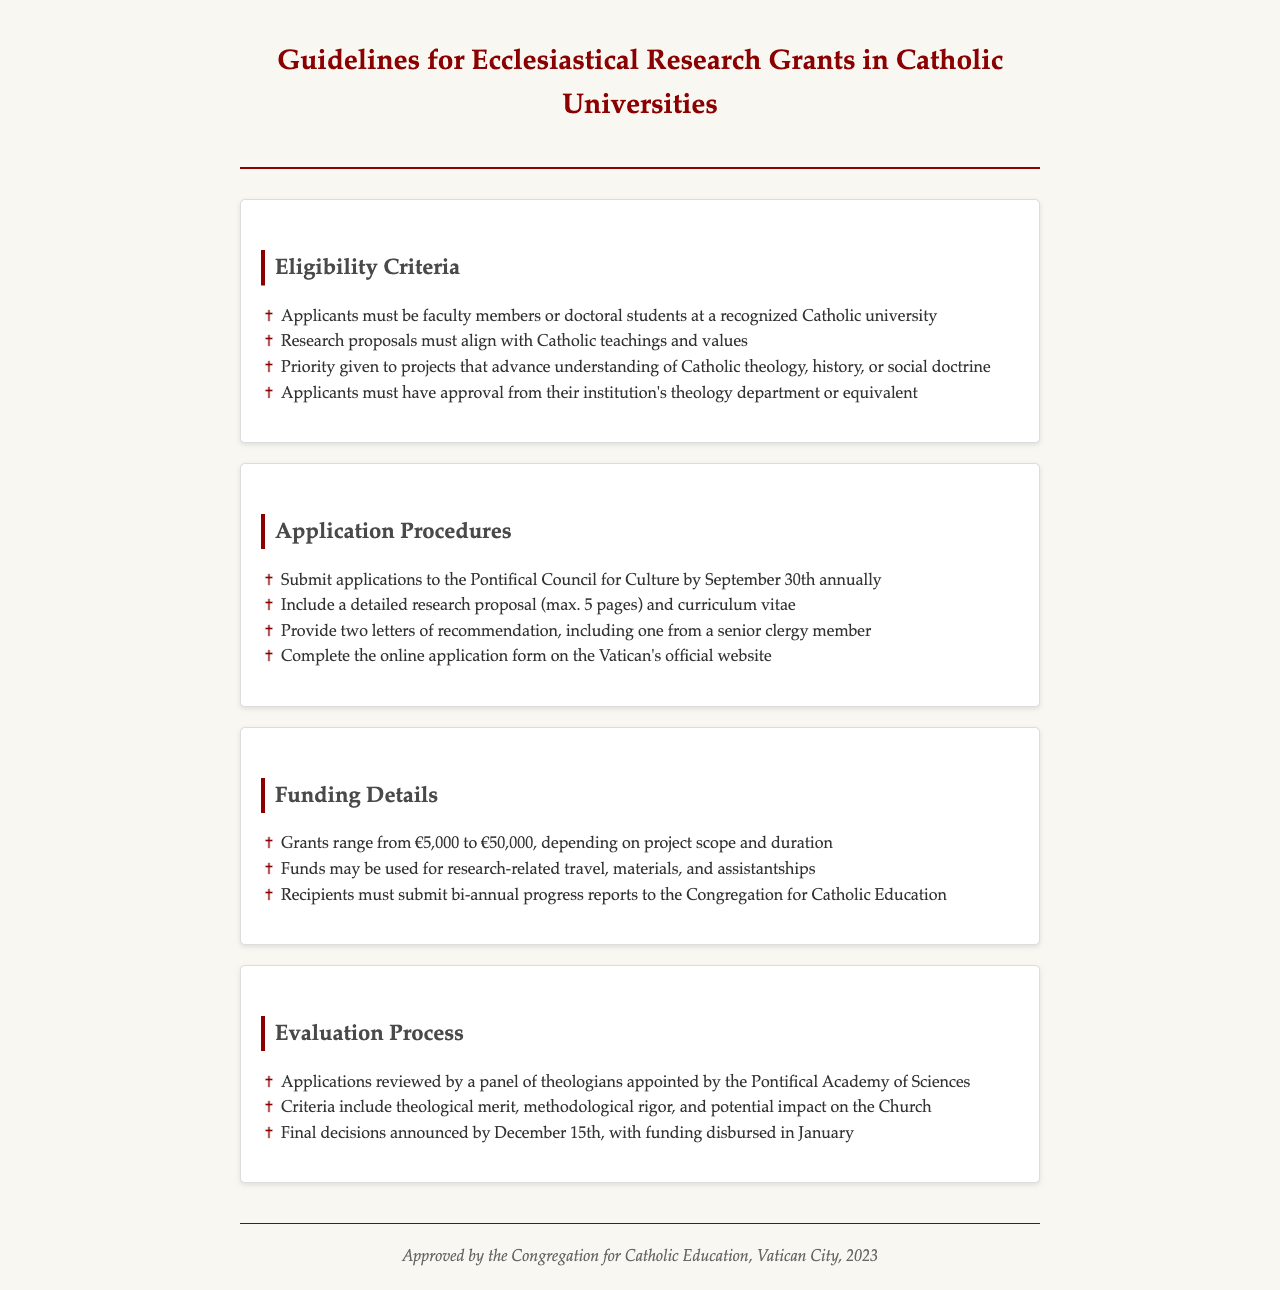What is the maximum length of the research proposal? The document specifies that the research proposal must be a maximum of 5 pages long.
Answer: 5 pages Who must approve the applications? According to the document, applicants must have approval from their institution's theology department or equivalent.
Answer: theology department What is the range of grant amounts available? The document indicates that grants range from €5,000 to €50,000.
Answer: €5,000 to €50,000 When is the application deadline? The document states that applications must be submitted by September 30th annually.
Answer: September 30th Which council do applications need to be submitted to? The document specifies that applications should be submitted to the Pontifical Council for Culture.
Answer: Pontifical Council for Culture What is the evaluation panel composed of? The document mentions that applications are reviewed by a panel of theologians appointed by the Pontifical Academy of Sciences.
Answer: theologians What is a requirement regarding letters of recommendation? The document requires that applicants provide two letters of recommendation, including one from a senior clergy member.
Answer: one from a senior clergy member What is the purpose of the bi-annual progress reports? The document states that recipients must submit bi-annual progress reports to the Congregation for Catholic Education.
Answer: Congregation for Catholic Education 